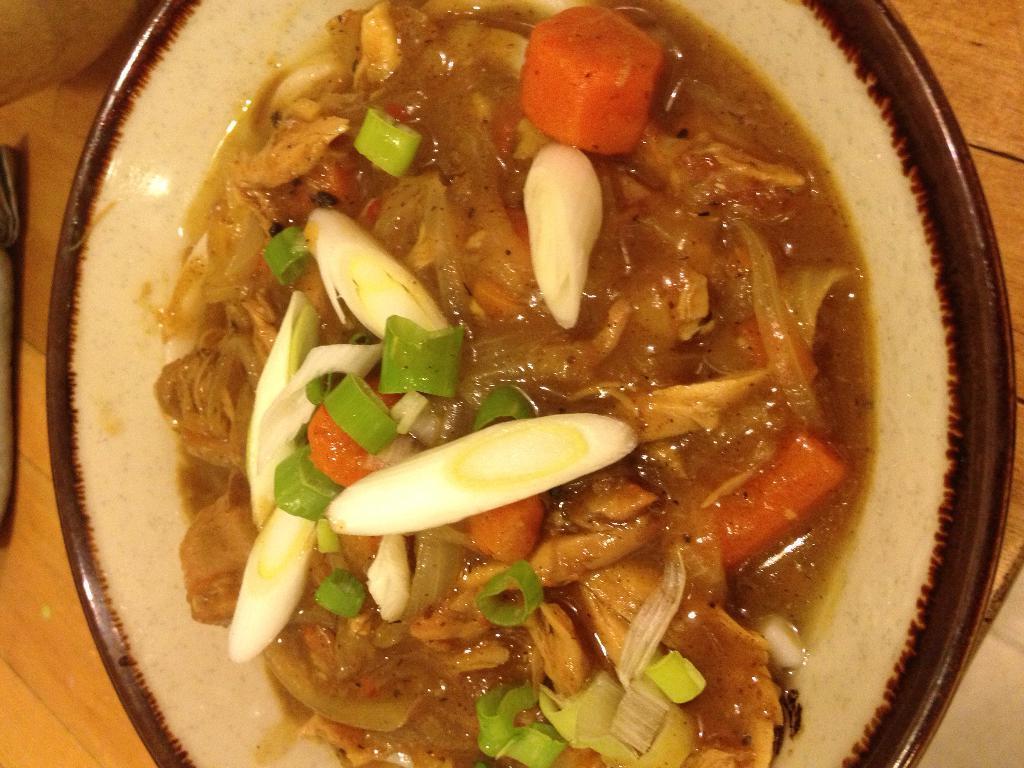In one or two sentences, can you explain what this image depicts? In this picture, we see a plate containing the food item is placed on the wooden table. On the left side, we see an object in black color is placed on the table. 